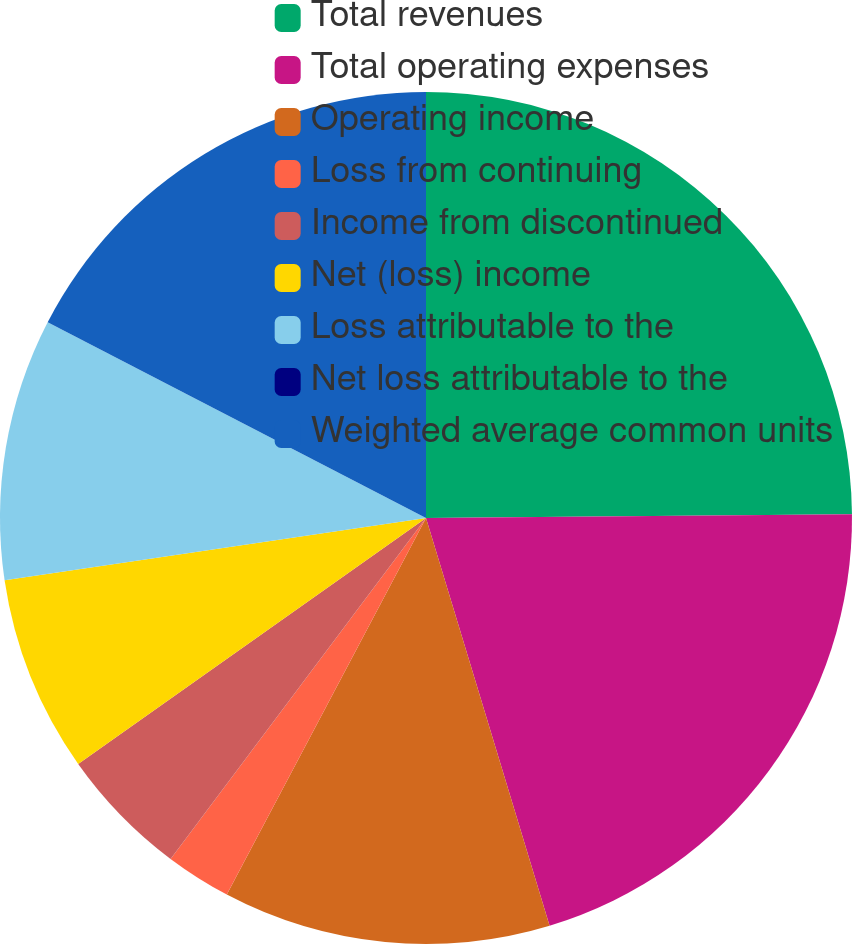<chart> <loc_0><loc_0><loc_500><loc_500><pie_chart><fcel>Total revenues<fcel>Total operating expenses<fcel>Operating income<fcel>Loss from continuing<fcel>Income from discontinued<fcel>Net (loss) income<fcel>Loss attributable to the<fcel>Net loss attributable to the<fcel>Weighted average common units<nl><fcel>24.86%<fcel>20.46%<fcel>12.43%<fcel>2.49%<fcel>4.97%<fcel>7.46%<fcel>9.94%<fcel>0.0%<fcel>17.4%<nl></chart> 